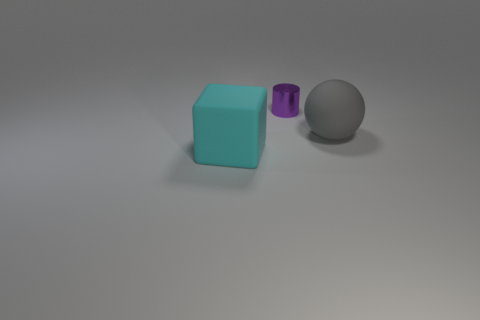The thing behind the big gray rubber thing has what shape? cylinder 